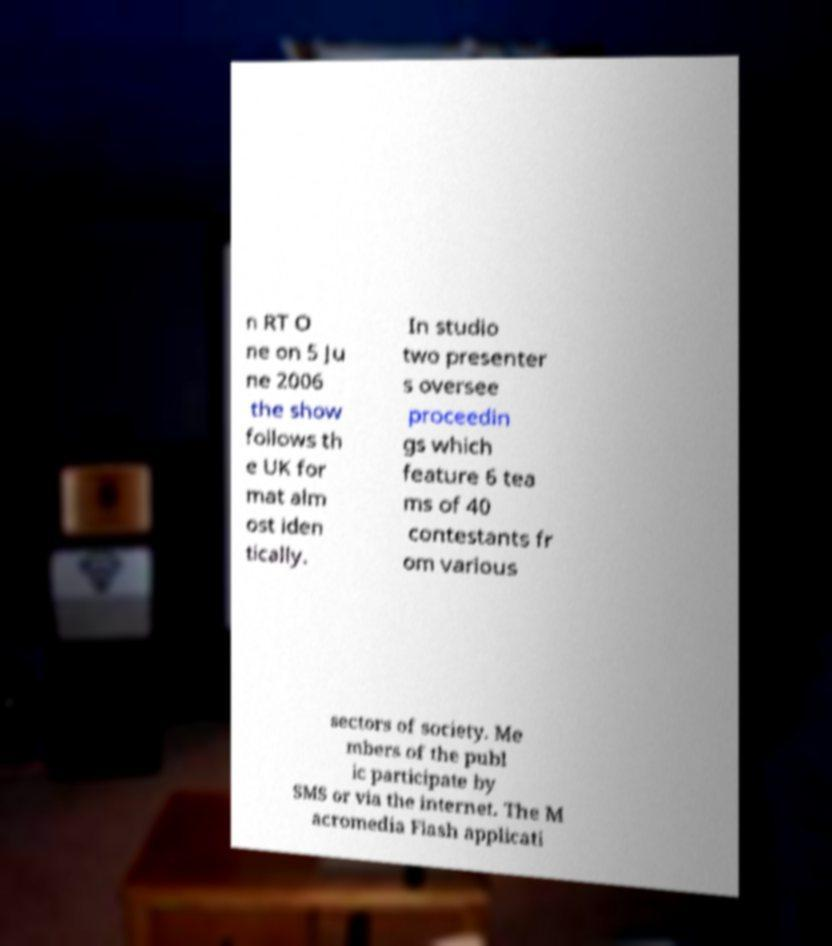Could you assist in decoding the text presented in this image and type it out clearly? n RT O ne on 5 Ju ne 2006 the show follows th e UK for mat alm ost iden tically. In studio two presenter s oversee proceedin gs which feature 6 tea ms of 40 contestants fr om various sectors of society. Me mbers of the publ ic participate by SMS or via the internet. The M acromedia Flash applicati 